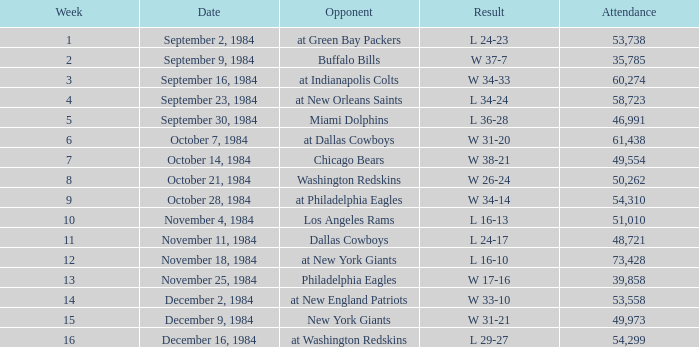What is the sum of attendance when the result was l 16-13? 51010.0. 